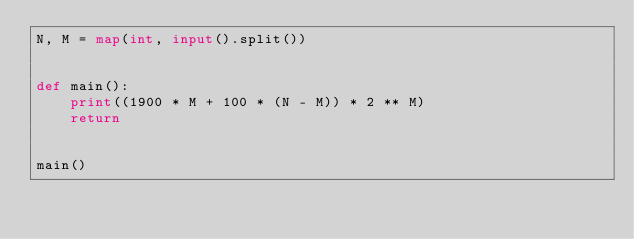Convert code to text. <code><loc_0><loc_0><loc_500><loc_500><_Python_>N, M = map(int, input().split())


def main():
    print((1900 * M + 100 * (N - M)) * 2 ** M)
    return


main()
</code> 